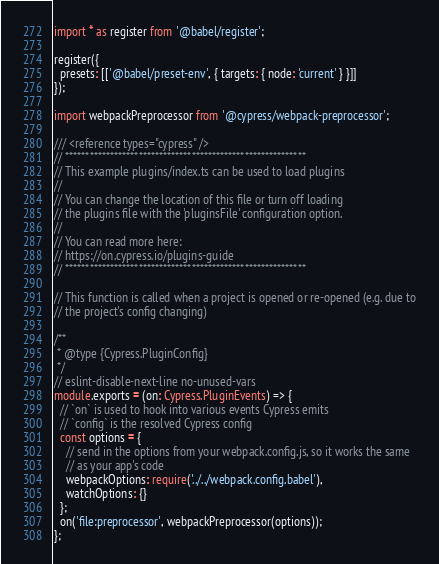<code> <loc_0><loc_0><loc_500><loc_500><_TypeScript_>import * as register from '@babel/register';

register({
  presets: [['@babel/preset-env', { targets: { node: 'current' } }]]
});

import webpackPreprocessor from '@cypress/webpack-preprocessor';

/// <reference types="cypress" />
// ***********************************************************
// This example plugins/index.ts can be used to load plugins
//
// You can change the location of this file or turn off loading
// the plugins file with the 'pluginsFile' configuration option.
//
// You can read more here:
// https://on.cypress.io/plugins-guide
// ***********************************************************

// This function is called when a project is opened or re-opened (e.g. due to
// the project's config changing)

/**
 * @type {Cypress.PluginConfig}
 */
// eslint-disable-next-line no-unused-vars
module.exports = (on: Cypress.PluginEvents) => {
  // `on` is used to hook into various events Cypress emits
  // `config` is the resolved Cypress config
  const options = {
    // send in the options from your webpack.config.js, so it works the same
    // as your app's code
    webpackOptions: require('../../webpack.config.babel'),
    watchOptions: {}
  };
  on('file:preprocessor', webpackPreprocessor(options));
};
</code> 